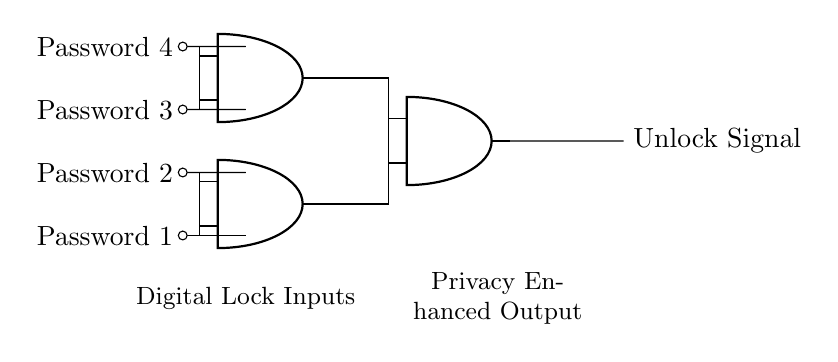What are the inputs of the circuit? The inputs of the circuit are Password 1, Password 2, Password 3, and Password 4, which are represented on the left side of the diagram.
Answer: Password 1, Password 2, Password 3, Password 4 How many AND gates are used in this circuit? The circuit features three AND gates, as indicated by the symbols labeled as AND ports in the diagram.
Answer: Three What is the output signal of this circuit? The output signal, which indicates the unlocking action, is labeled as "Unlock Signal" on the right side of the diagram.
Answer: Unlock Signal Which two inputs connect to the first AND gate? The first AND gate connects to Password 1 and Password 2, as shown by the lines connecting the inputs to the gate in the diagram.
Answer: Password 1, Password 2 What must occur at the AND gates for the Unlock Signal to be generated? For the Unlock Signal to be generated, AND gate conditions must be satisfied, meaning that both inputs to each AND gate must be true (high). This indicates that a valid password combination is required.
Answer: Both inputs must be true Which AND gate has the output connected to the last AND gate? The output from the first AND gate and the second AND gate are both connected to the last AND gate, allowing it to combine their outputs before determining the final Unlock Signal.
Answer: First and second AND gates 